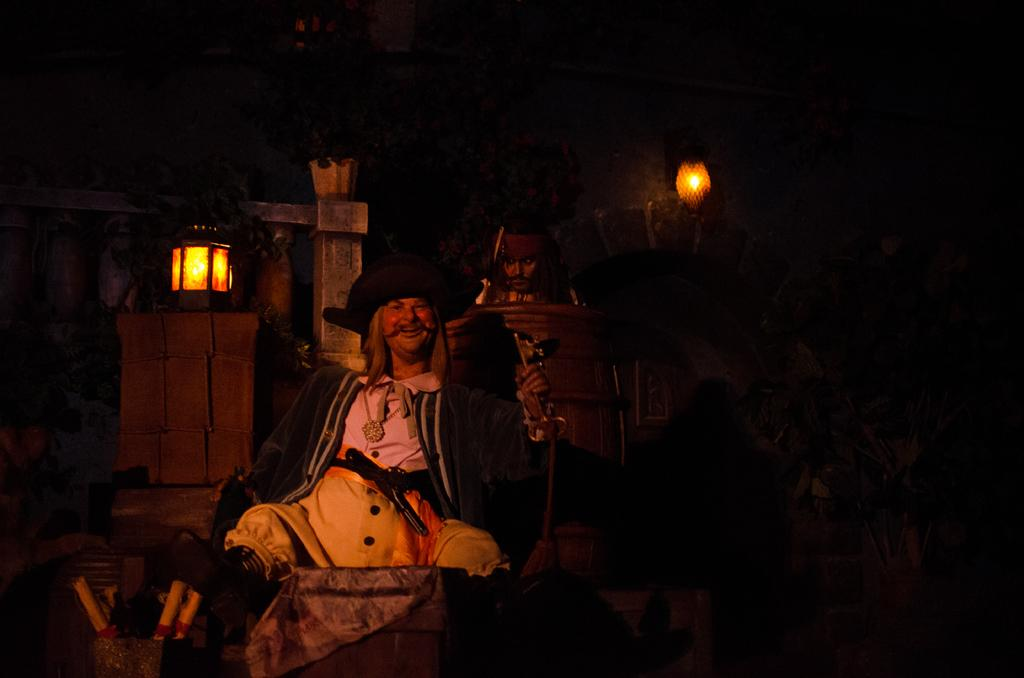What is the person sitting in the image dressed as? The person sitting in the image is dressed in a pirate costume. What is the person standing inside in the image? The person standing inside in the image is inside a barrel. What can be seen at the back of the scene? There are lamps at the back of the scene. What type of belief is being practiced in the park in the image? There is no park or any indication of a belief being practiced in the image. 